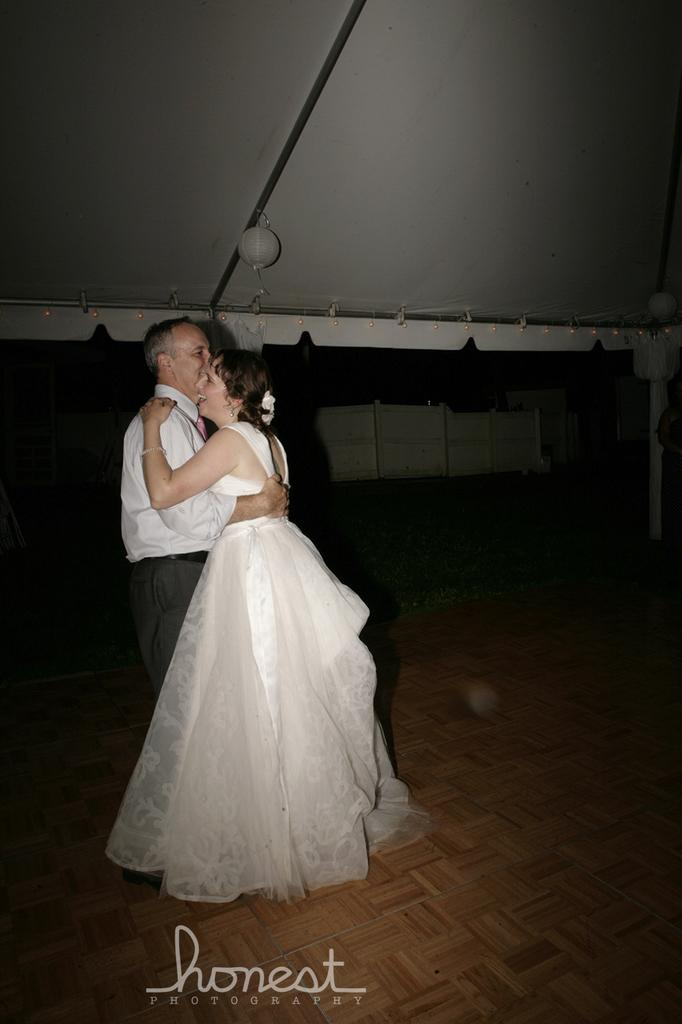Who is present in the image? There is a man and a woman in the image. What are the man and woman doing in the image? The man and woman are holding each other in the image. What can be found at the bottom of the image? There is some text at the bottom of the image. What is located on top of the image? There is a white object on top of the image. How many yaks are visible in the image? There are no yaks present in the image. What type of frame surrounds the image? The provided facts do not mention a frame surrounding the image. 